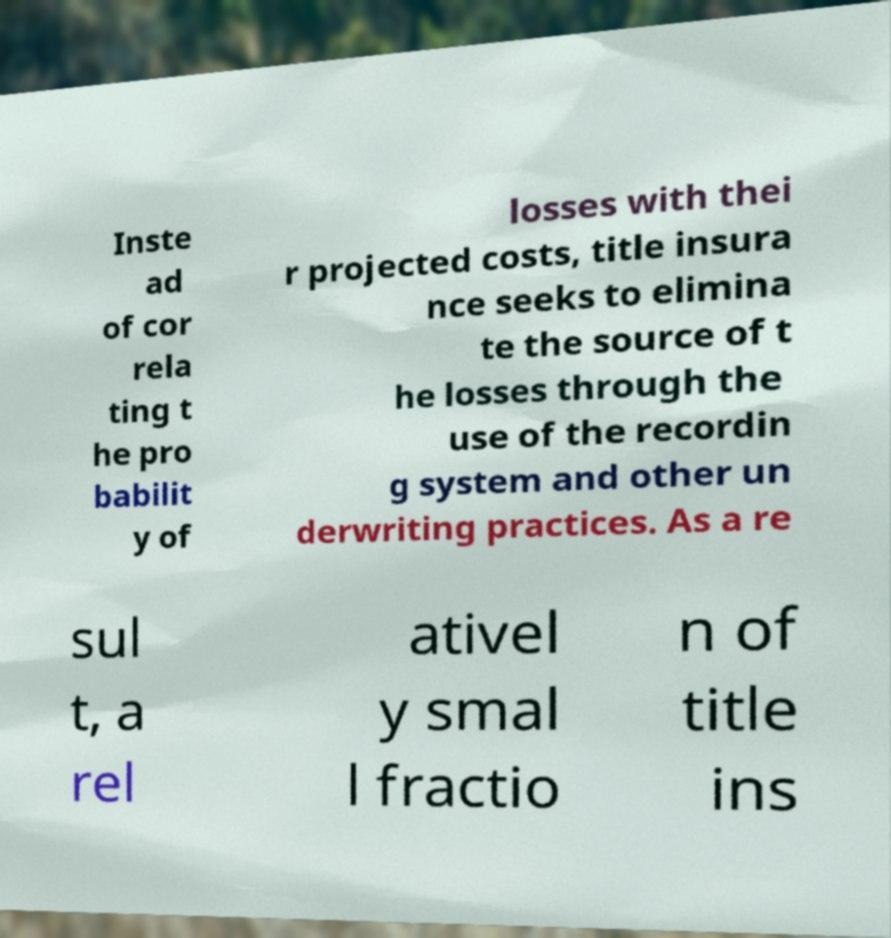Can you accurately transcribe the text from the provided image for me? Inste ad of cor rela ting t he pro babilit y of losses with thei r projected costs, title insura nce seeks to elimina te the source of t he losses through the use of the recordin g system and other un derwriting practices. As a re sul t, a rel ativel y smal l fractio n of title ins 